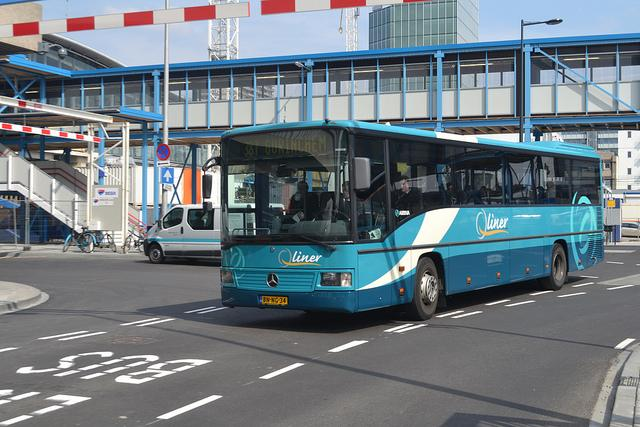What word is on the ground in white letters? bus 